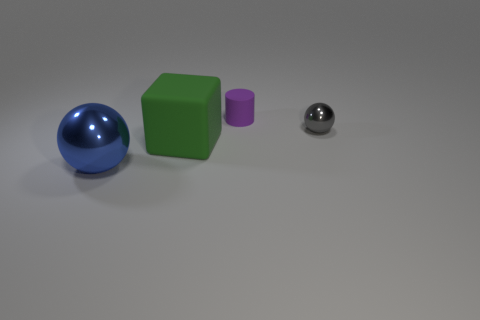Add 2 tiny gray things. How many objects exist? 6 Subtract all cylinders. How many objects are left? 3 Subtract all rubber cylinders. Subtract all green matte cubes. How many objects are left? 2 Add 3 blue shiny spheres. How many blue shiny spheres are left? 4 Add 4 red things. How many red things exist? 4 Subtract 0 brown cylinders. How many objects are left? 4 